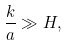Convert formula to latex. <formula><loc_0><loc_0><loc_500><loc_500>\frac { k } { a } \gg H ,</formula> 